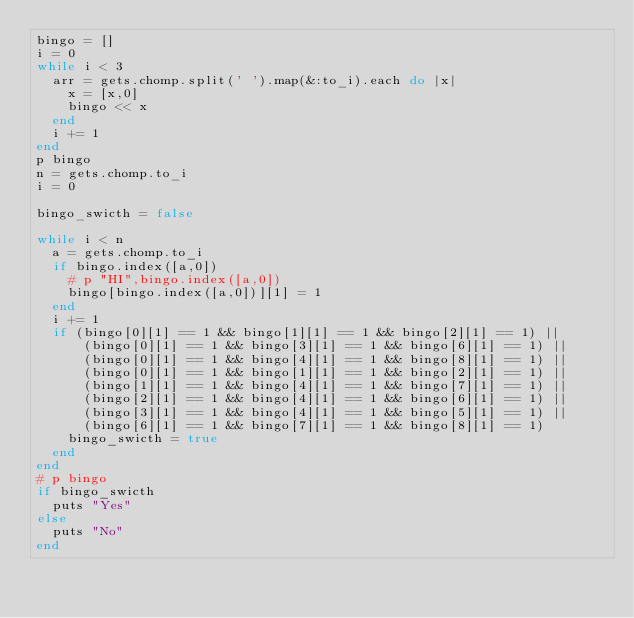Convert code to text. <code><loc_0><loc_0><loc_500><loc_500><_Ruby_>bingo = []
i = 0
while i < 3
  arr = gets.chomp.split(' ').map(&:to_i).each do |x|
    x = [x,0]
    bingo << x
  end
  i += 1
end
p bingo
n = gets.chomp.to_i
i = 0

bingo_swicth = false

while i < n
  a = gets.chomp.to_i
  if bingo.index([a,0])
    # p "HI",bingo.index([a,0])
    bingo[bingo.index([a,0])][1] = 1
  end
  i += 1
  if (bingo[0][1] == 1 && bingo[1][1] == 1 && bingo[2][1] == 1) || 
      (bingo[0][1] == 1 && bingo[3][1] == 1 && bingo[6][1] == 1) ||
      (bingo[0][1] == 1 && bingo[4][1] == 1 && bingo[8][1] == 1) ||
      (bingo[0][1] == 1 && bingo[1][1] == 1 && bingo[2][1] == 1) ||
      (bingo[1][1] == 1 && bingo[4][1] == 1 && bingo[7][1] == 1) ||
      (bingo[2][1] == 1 && bingo[4][1] == 1 && bingo[6][1] == 1) ||
      (bingo[3][1] == 1 && bingo[4][1] == 1 && bingo[5][1] == 1) ||
      (bingo[6][1] == 1 && bingo[7][1] == 1 && bingo[8][1] == 1)
    bingo_swicth = true
  end
end
# p bingo
if bingo_swicth
  puts "Yes"
else
  puts "No"
end</code> 